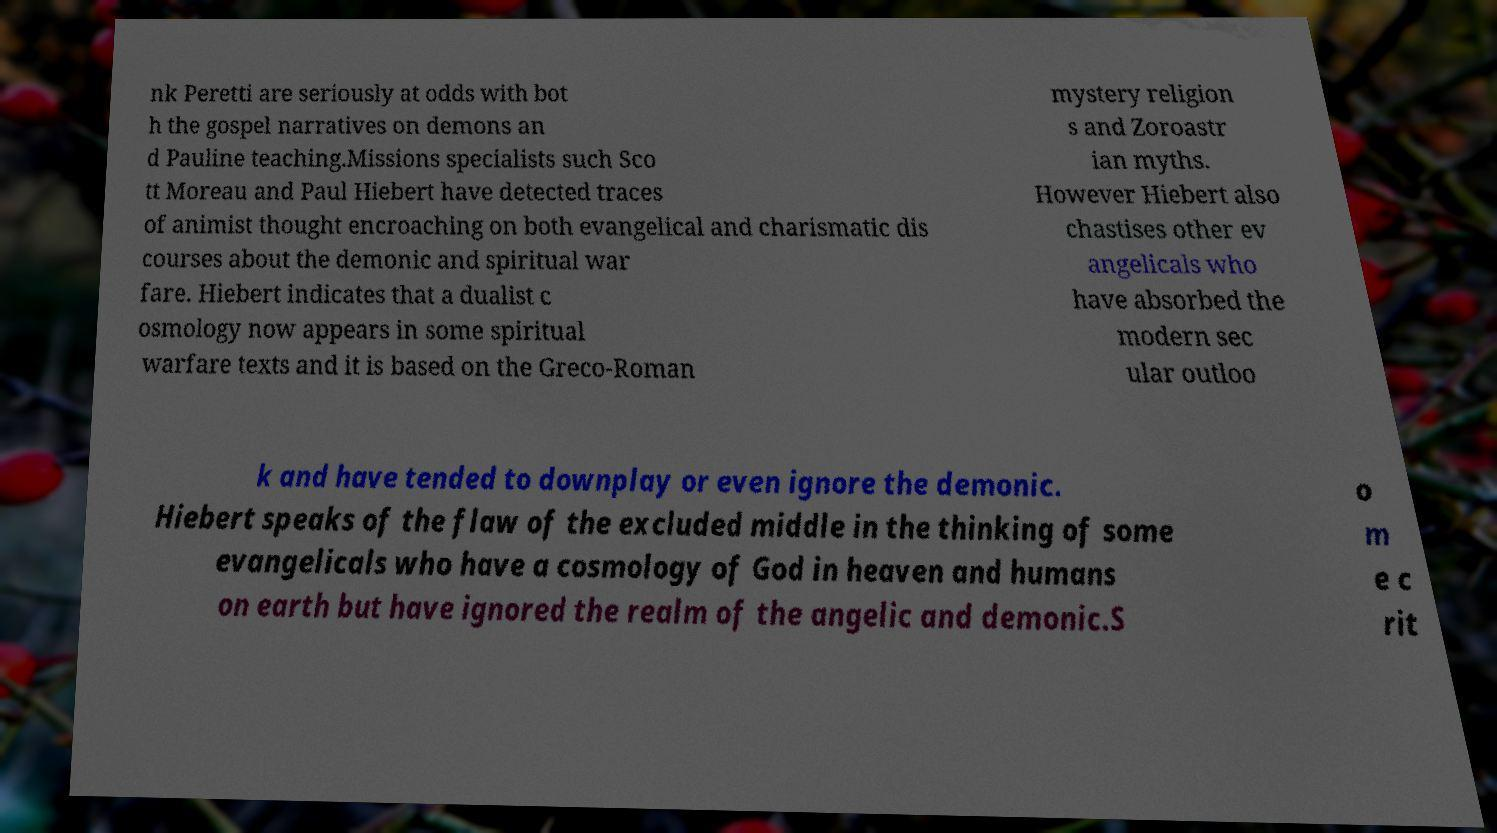Please read and relay the text visible in this image. What does it say? nk Peretti are seriously at odds with bot h the gospel narratives on demons an d Pauline teaching.Missions specialists such Sco tt Moreau and Paul Hiebert have detected traces of animist thought encroaching on both evangelical and charismatic dis courses about the demonic and spiritual war fare. Hiebert indicates that a dualist c osmology now appears in some spiritual warfare texts and it is based on the Greco-Roman mystery religion s and Zoroastr ian myths. However Hiebert also chastises other ev angelicals who have absorbed the modern sec ular outloo k and have tended to downplay or even ignore the demonic. Hiebert speaks of the flaw of the excluded middle in the thinking of some evangelicals who have a cosmology of God in heaven and humans on earth but have ignored the realm of the angelic and demonic.S o m e c rit 